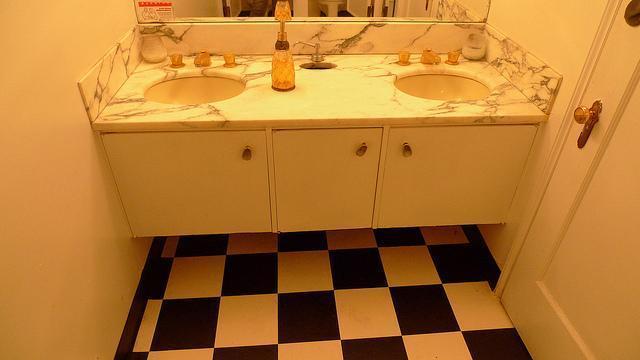How many chairs are at the table?
Give a very brief answer. 0. 